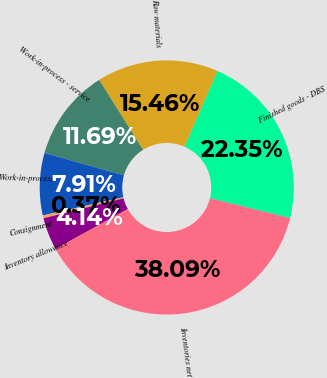<chart> <loc_0><loc_0><loc_500><loc_500><pie_chart><fcel>Finished goods - DBS<fcel>Raw materials<fcel>Work-in-process - service<fcel>Work-in-process<fcel>Consignment<fcel>Inventory allowance<fcel>Inventories net<nl><fcel>22.35%<fcel>15.46%<fcel>11.69%<fcel>7.91%<fcel>0.37%<fcel>4.14%<fcel>38.09%<nl></chart> 